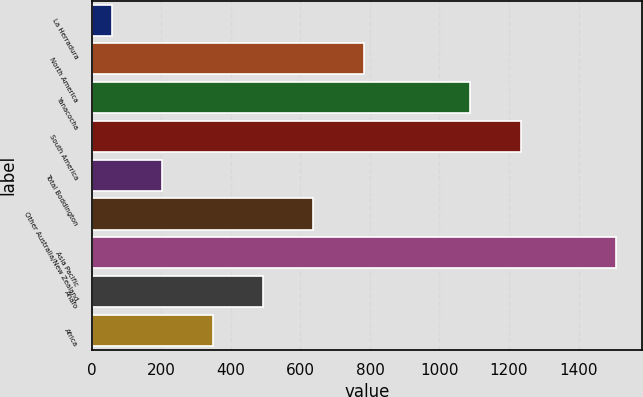Convert chart to OTSL. <chart><loc_0><loc_0><loc_500><loc_500><bar_chart><fcel>La Herradura<fcel>North America<fcel>Yanacocha<fcel>South America<fcel>Total Boddington<fcel>Other Australia/New Zealand<fcel>Asia Pacific<fcel>Ahafo<fcel>Africa<nl><fcel>57<fcel>782<fcel>1089<fcel>1234<fcel>202<fcel>637<fcel>1507<fcel>492<fcel>347<nl></chart> 